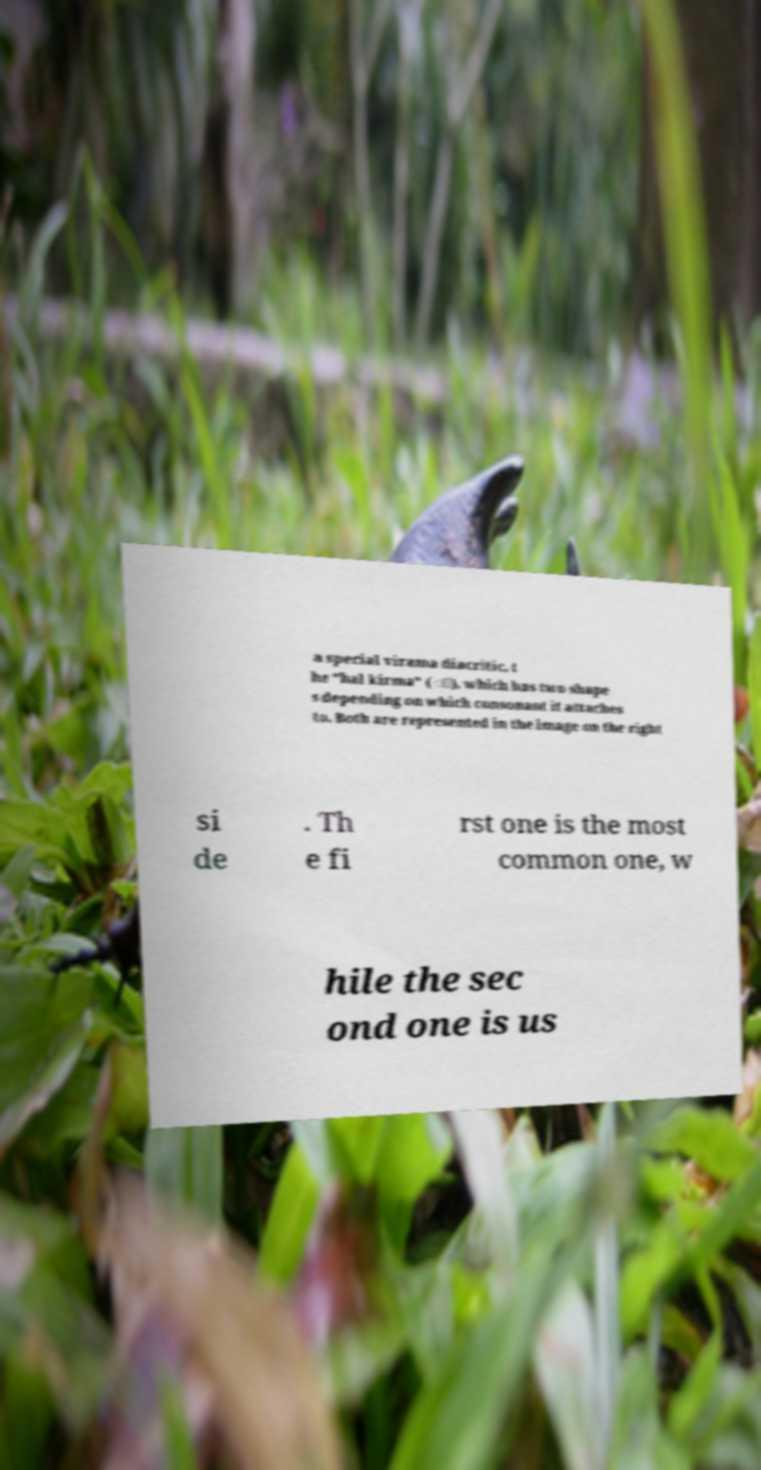Please identify and transcribe the text found in this image. a special virama diacritic, t he "hal kirma" ( ්), which has two shape s depending on which consonant it attaches to. Both are represented in the image on the right si de . Th e fi rst one is the most common one, w hile the sec ond one is us 